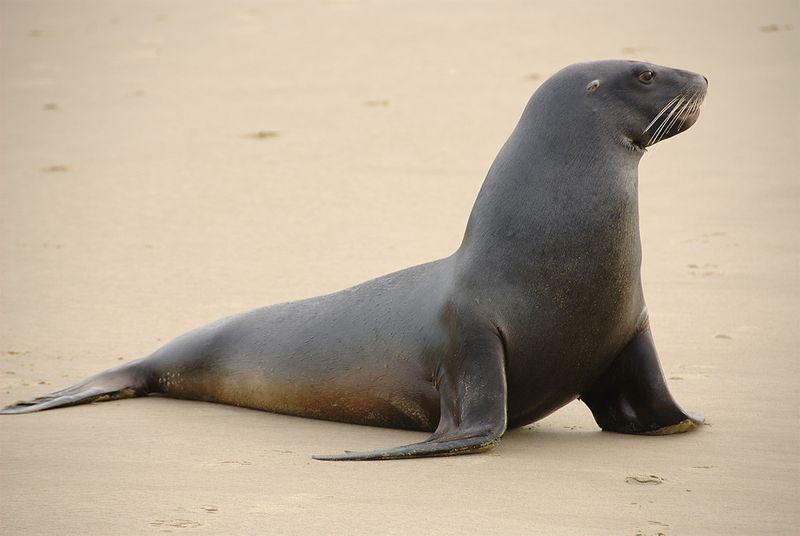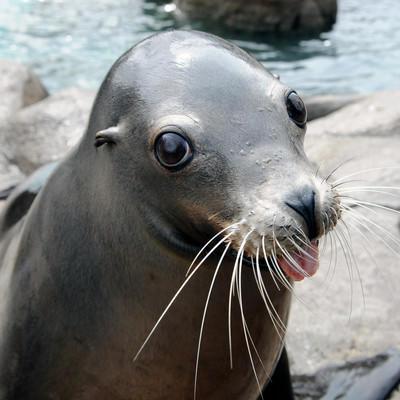The first image is the image on the left, the second image is the image on the right. For the images displayed, is the sentence "One image shows a seal on sand without water clearly visible." factually correct? Answer yes or no. Yes. The first image is the image on the left, the second image is the image on the right. Given the left and right images, does the statement "There is exactly one seal in the image on the left." hold true? Answer yes or no. Yes. The first image is the image on the left, the second image is the image on the right. For the images displayed, is the sentence "Blue water is visible in both images of seals." factually correct? Answer yes or no. No. The first image is the image on the left, the second image is the image on the right. For the images shown, is this caption "There is more than one seal in at least one image." true? Answer yes or no. No. 